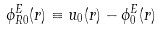<formula> <loc_0><loc_0><loc_500><loc_500>\phi _ { R 0 } ^ { E } ( r ) \equiv u _ { 0 } ( r ) - \phi _ { 0 } ^ { E } ( r )</formula> 